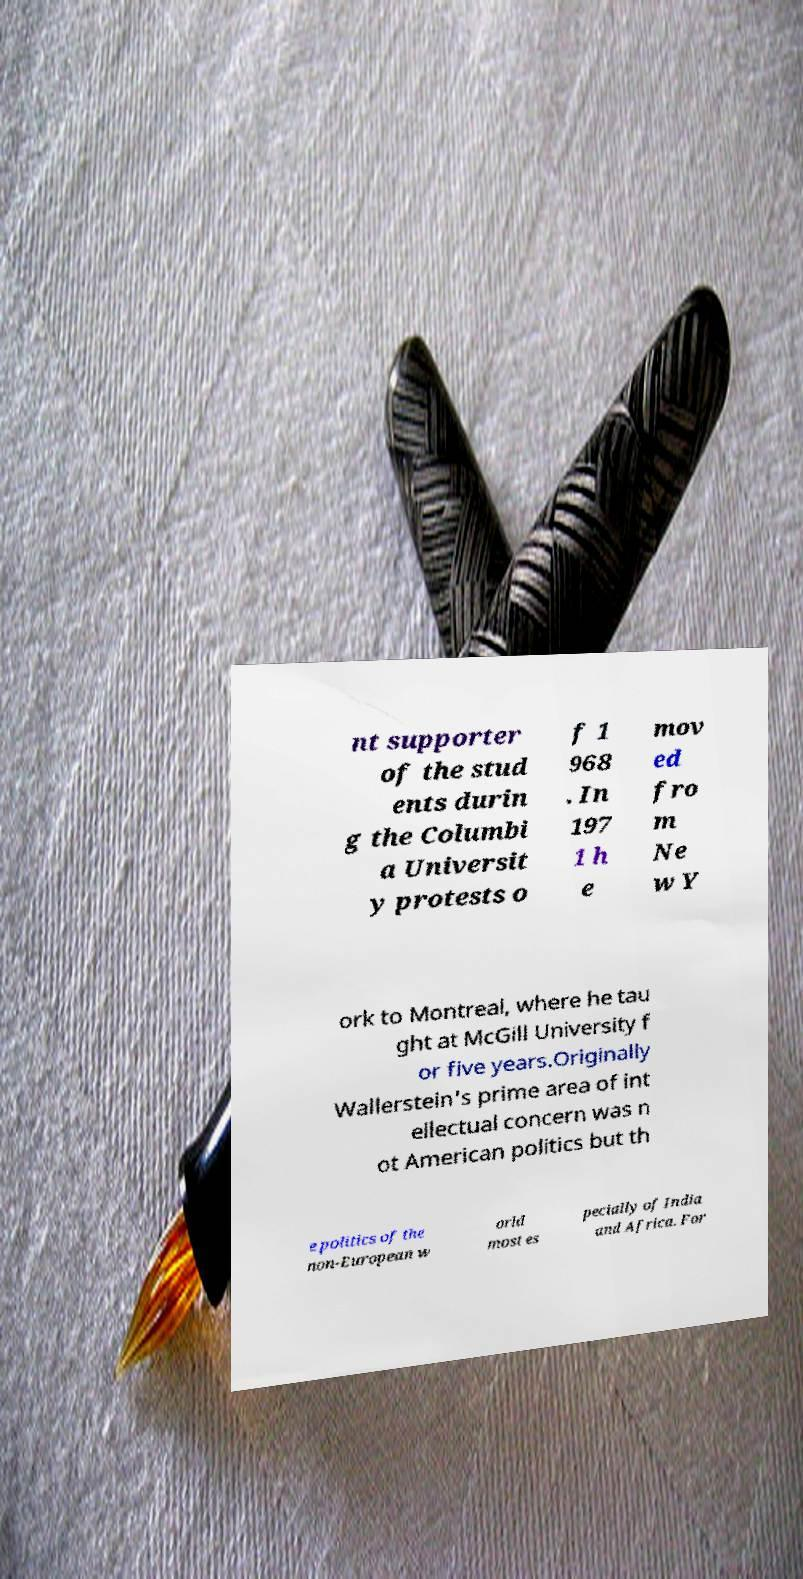For documentation purposes, I need the text within this image transcribed. Could you provide that? nt supporter of the stud ents durin g the Columbi a Universit y protests o f 1 968 . In 197 1 h e mov ed fro m Ne w Y ork to Montreal, where he tau ght at McGill University f or five years.Originally Wallerstein's prime area of int ellectual concern was n ot American politics but th e politics of the non-European w orld most es pecially of India and Africa. For 